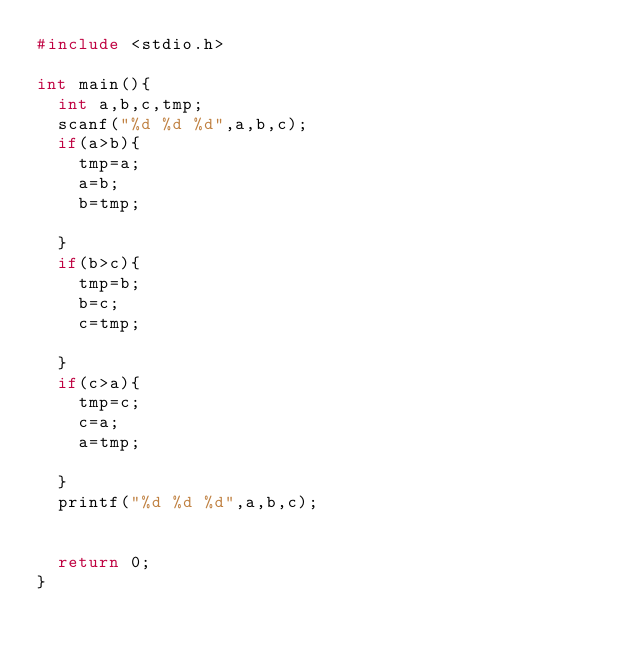<code> <loc_0><loc_0><loc_500><loc_500><_C_>#include <stdio.h>

int main(){
  int a,b,c,tmp;
  scanf("%d %d %d",a,b,c);
  if(a>b){
    tmp=a;
    a=b;
    b=tmp;

  }
  if(b>c){
    tmp=b;
    b=c;
    c=tmp;

  }
  if(c>a){
    tmp=c;
    c=a;
    a=tmp;

  }
  printf("%d %d %d",a,b,c);
  
  
  return 0;
}</code> 